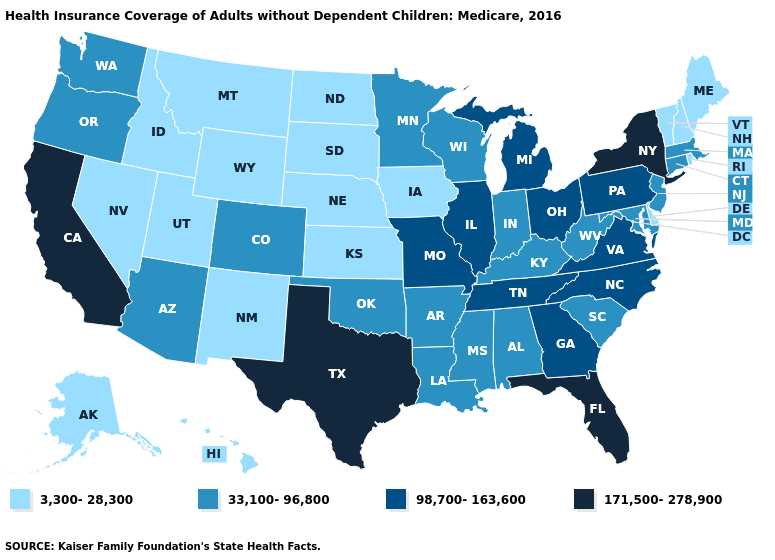Is the legend a continuous bar?
Give a very brief answer. No. Name the states that have a value in the range 3,300-28,300?
Write a very short answer. Alaska, Delaware, Hawaii, Idaho, Iowa, Kansas, Maine, Montana, Nebraska, Nevada, New Hampshire, New Mexico, North Dakota, Rhode Island, South Dakota, Utah, Vermont, Wyoming. Name the states that have a value in the range 171,500-278,900?
Concise answer only. California, Florida, New York, Texas. What is the lowest value in the Northeast?
Be succinct. 3,300-28,300. Does Delaware have the lowest value in the South?
Quick response, please. Yes. Name the states that have a value in the range 33,100-96,800?
Keep it brief. Alabama, Arizona, Arkansas, Colorado, Connecticut, Indiana, Kentucky, Louisiana, Maryland, Massachusetts, Minnesota, Mississippi, New Jersey, Oklahoma, Oregon, South Carolina, Washington, West Virginia, Wisconsin. Among the states that border Georgia , which have the lowest value?
Be succinct. Alabama, South Carolina. How many symbols are there in the legend?
Write a very short answer. 4. What is the highest value in the Northeast ?
Give a very brief answer. 171,500-278,900. How many symbols are there in the legend?
Be succinct. 4. What is the value of Alaska?
Quick response, please. 3,300-28,300. Does Kentucky have the lowest value in the USA?
Concise answer only. No. What is the highest value in the MidWest ?
Short answer required. 98,700-163,600. Name the states that have a value in the range 3,300-28,300?
Be succinct. Alaska, Delaware, Hawaii, Idaho, Iowa, Kansas, Maine, Montana, Nebraska, Nevada, New Hampshire, New Mexico, North Dakota, Rhode Island, South Dakota, Utah, Vermont, Wyoming. Among the states that border Connecticut , does Rhode Island have the lowest value?
Concise answer only. Yes. 